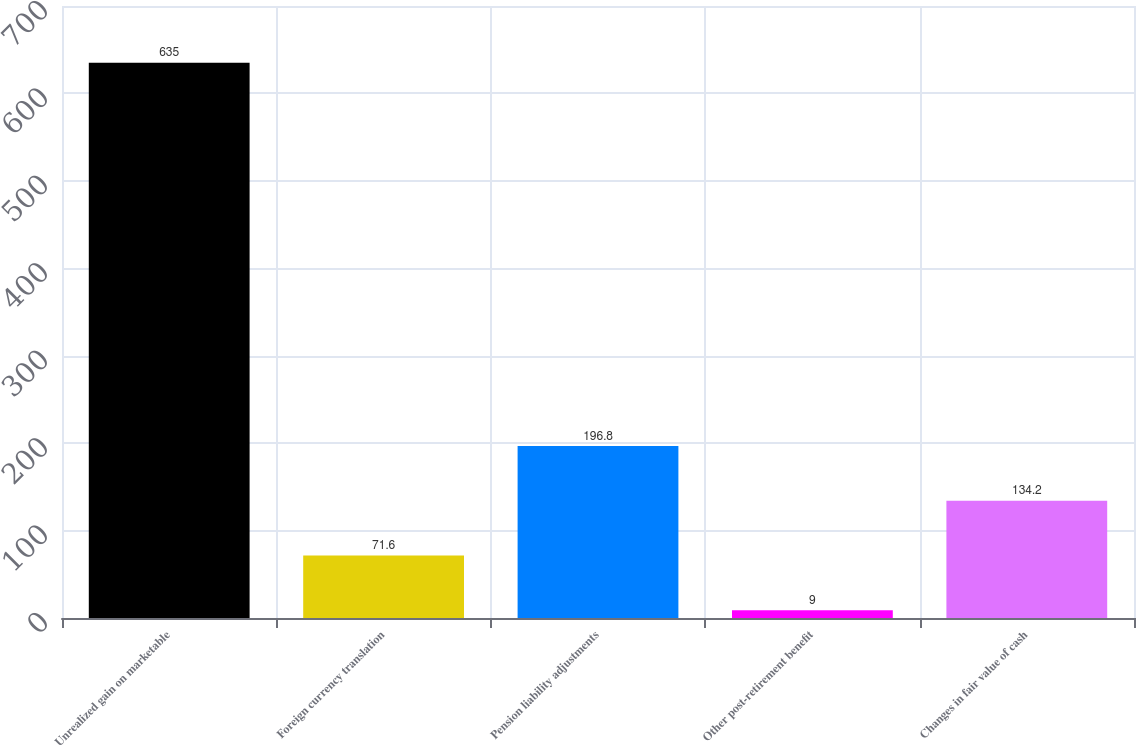Convert chart to OTSL. <chart><loc_0><loc_0><loc_500><loc_500><bar_chart><fcel>Unrealized gain on marketable<fcel>Foreign currency translation<fcel>Pension liability adjustments<fcel>Other post-retirement benefit<fcel>Changes in fair value of cash<nl><fcel>635<fcel>71.6<fcel>196.8<fcel>9<fcel>134.2<nl></chart> 